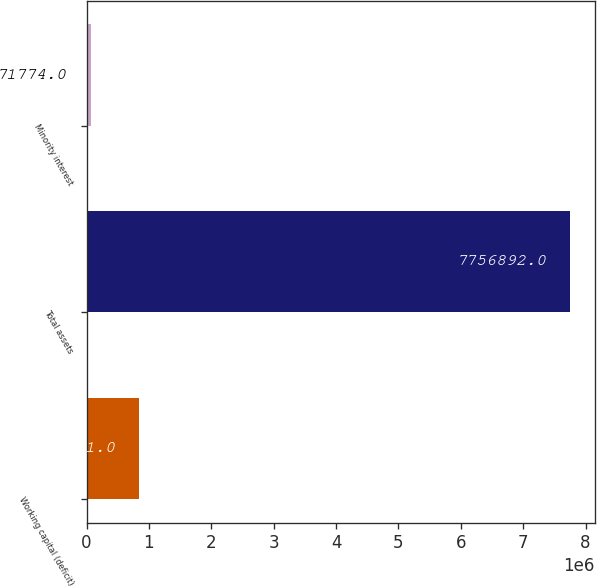Convert chart to OTSL. <chart><loc_0><loc_0><loc_500><loc_500><bar_chart><fcel>Working capital (deficit)<fcel>Total assets<fcel>Minority interest<nl><fcel>847981<fcel>7.75689e+06<fcel>71774<nl></chart> 